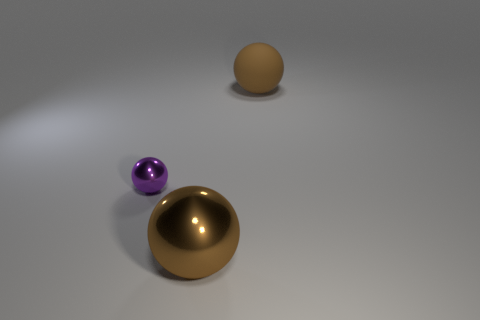Is the color of the large metal sphere the same as the matte ball?
Keep it short and to the point. Yes. There is a brown metal object to the left of the big matte object; is there a small ball in front of it?
Make the answer very short. No. There is a rubber object that is the same shape as the small purple metal object; what color is it?
Your response must be concise. Brown. How many other big things are the same color as the rubber thing?
Your answer should be very brief. 1. There is a metallic thing behind the brown sphere that is left of the ball that is behind the purple metallic object; what color is it?
Give a very brief answer. Purple. Is the purple shiny thing the same shape as the brown rubber thing?
Provide a short and direct response. Yes. Are there an equal number of things behind the tiny purple metal thing and large brown spheres that are to the right of the big metallic object?
Offer a terse response. Yes. There is a object that is made of the same material as the tiny purple ball; what is its color?
Offer a very short reply. Brown. How many brown spheres are the same material as the purple thing?
Your answer should be compact. 1. Do the big thing that is in front of the brown rubber thing and the big matte object have the same color?
Your answer should be compact. Yes. 